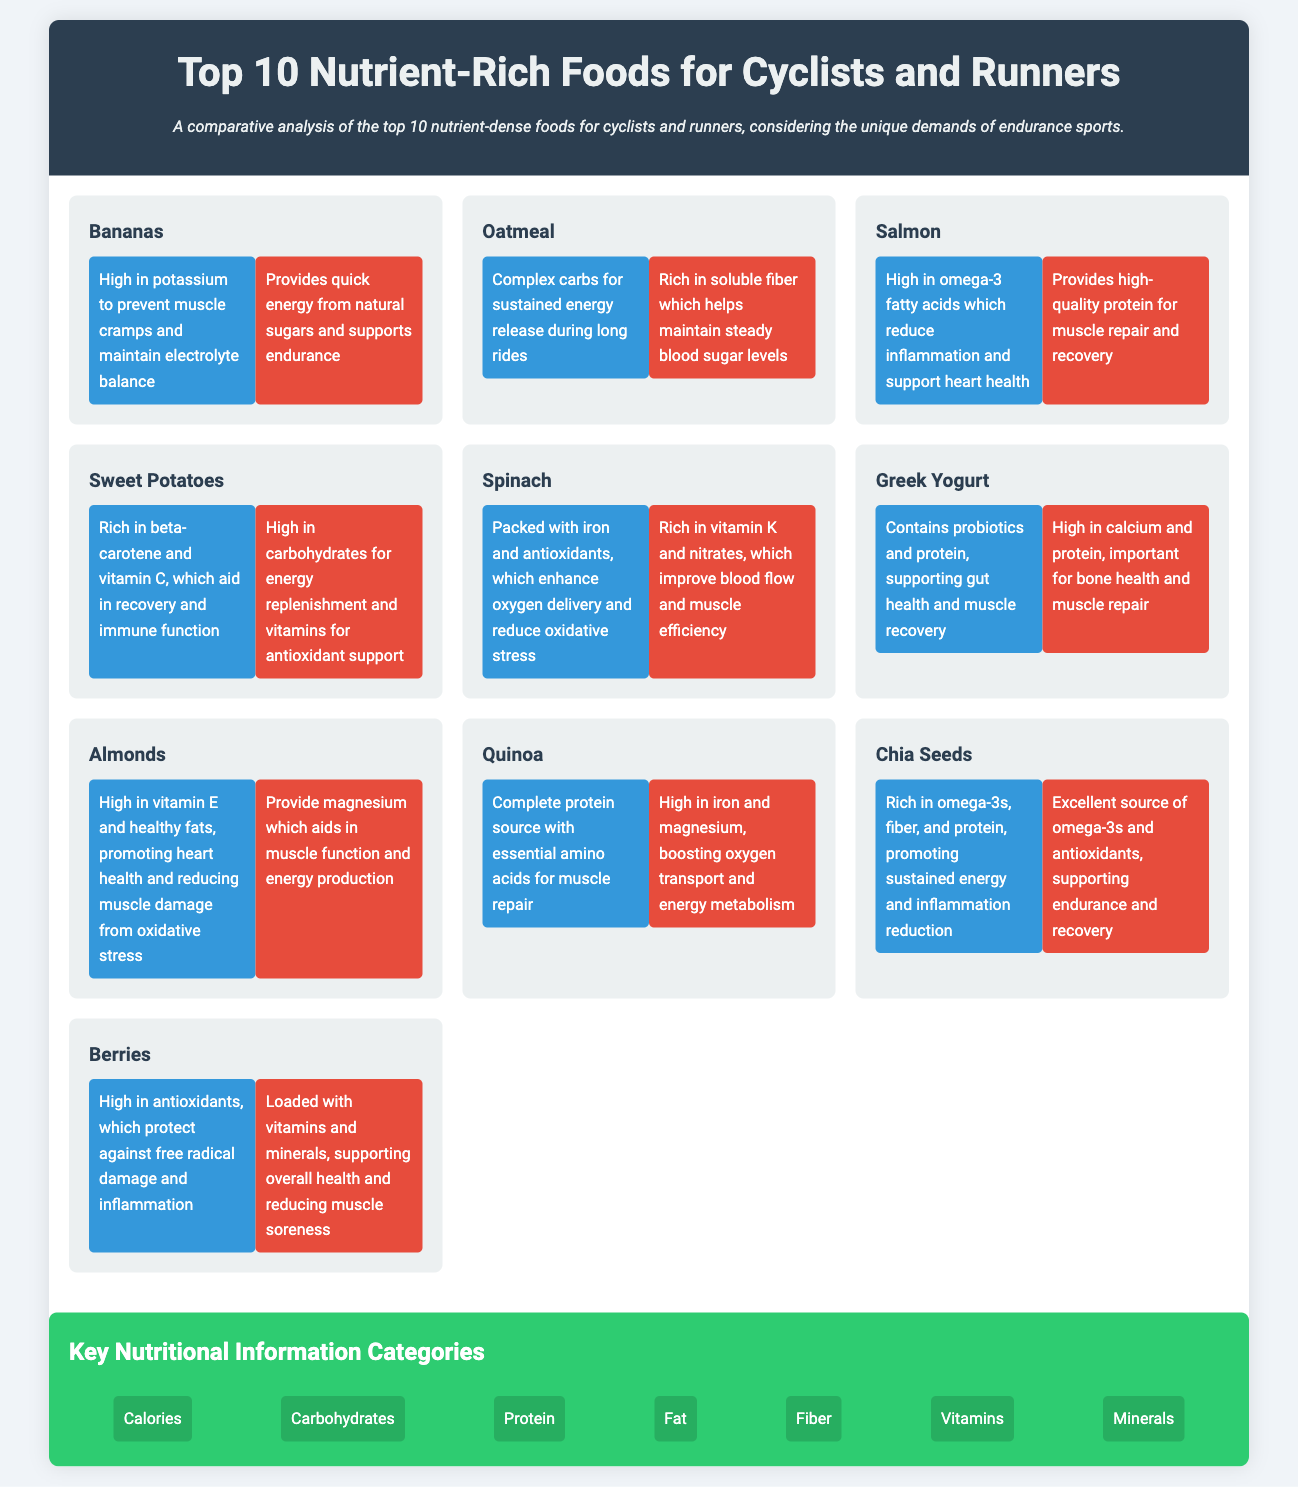What is the title of the infographic? The title of the infographic is prominently displayed at the top of the document.
Answer: Top 10 Nutrient-Rich Foods for Cyclists and Runners How many foods are listed in the infographic? The document outlines a total of ten nutrient-rich foods for both disciplines.
Answer: 10 What is a benefit of bananas for cyclists? The cyclist benefits of bananas include specific advantages that cater to their unique needs.
Answer: High in potassium to prevent muscle cramps and maintain electrolyte balance Which food provides quick energy for runners? The infographic describes one food that offers essential energy for runners prior to events.
Answer: Bananas What nutrients are highlighted in the key nutritional information? The infographic lists key nutritional categories that are relevant for both cyclists and runners.
Answer: Calories, Carbohydrates, Protein, Fat, Fiber, Vitamins, Minerals Which food contains omega-3 fatty acids? One specific food mentioned offers a rich source of omega-3 fatty acids, tailored for both athletes.
Answer: Salmon What is the primary function of oatmeal for runners? The benefits for runners include details on how oatmeal supports their athletic performance.
Answer: Rich in soluble fiber which helps maintain steady blood sugar levels What color represents the cyclist benefits section? The visual representation includes color coding to distinguish between cyclist and runner benefits.
Answer: Blue Which food is considered a complete protein source? The infographic identifies one food recognized for delivering complete nutritional value.
Answer: Quinoa What is the background color of the nutrition information section? The design elements of the document incorporate different colors for visual appeal and differentiation.
Answer: Green 